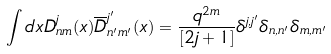<formula> <loc_0><loc_0><loc_500><loc_500>\int d x D _ { n m } ^ { j } ( x ) \overline { D } _ { n ^ { \prime } m ^ { \prime } } ^ { j ^ { \prime } } ( x ) = \frac { q ^ { 2 m } } { [ 2 j + 1 ] } \delta ^ { j , j ^ { \prime } } \delta _ { n , n ^ { \prime } } \delta _ { m , m ^ { \prime } }</formula> 